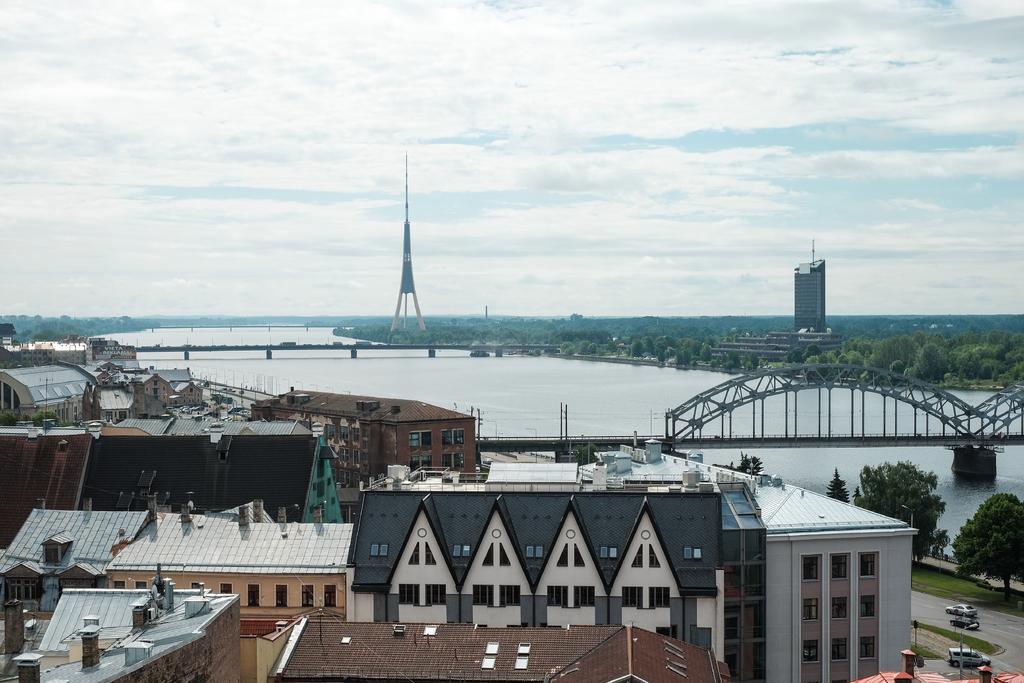Describe this image in one or two sentences. In this image I can see buildings, a bridge, vehicles on the road and water. In the background I can see trees, tower and the sky. 